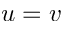Convert formula to latex. <formula><loc_0><loc_0><loc_500><loc_500>u = v</formula> 